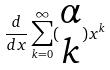Convert formula to latex. <formula><loc_0><loc_0><loc_500><loc_500>\frac { d } { d x } \sum _ { k = 0 } ^ { \infty } ( \begin{matrix} \alpha \\ k \end{matrix} ) x ^ { k }</formula> 